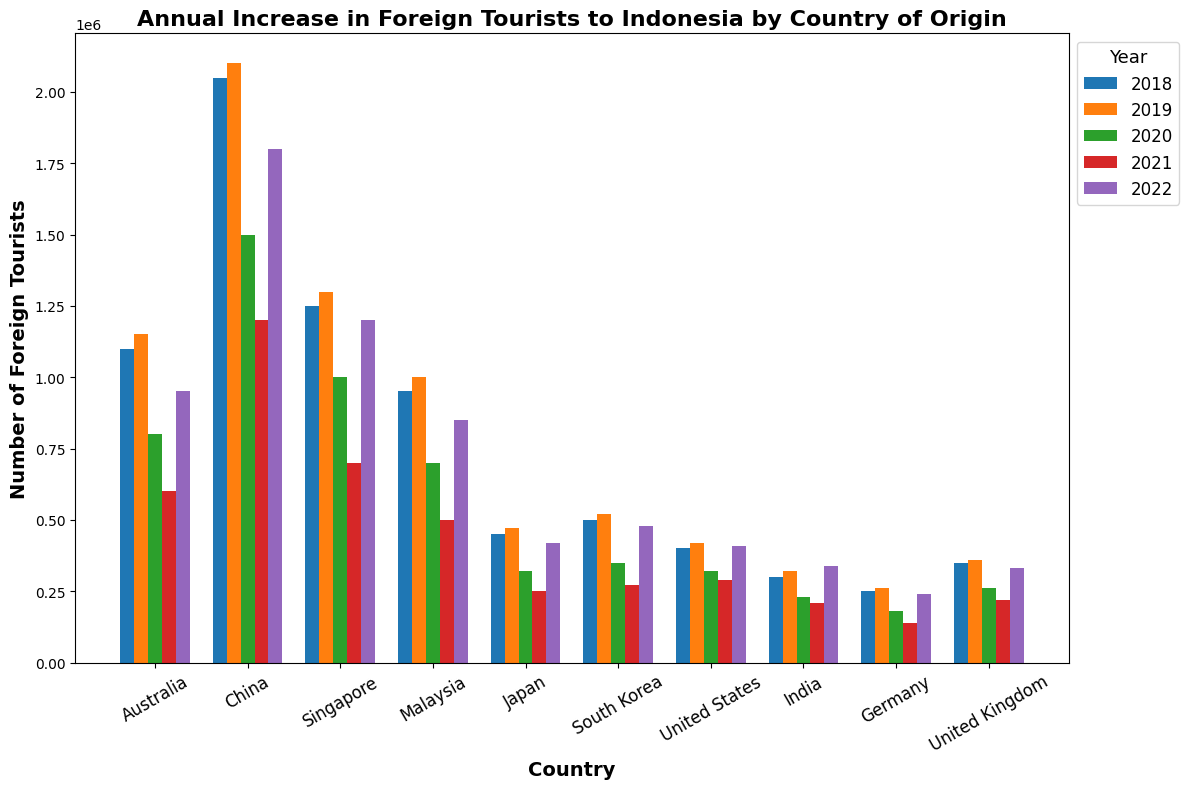Which country had the highest number of foreign tourists to Indonesia in 2022? By looking at the height of the bars for 2022, we can see that China had the highest number of foreign tourists.
Answer: China Which two countries had the least number of foreign tourists to Indonesia in 2021? By observing the bar heights for 2021, we can see that Germany and the United Kingdom had the least number of tourists.
Answer: Germany and United Kingdom What was the difference in the number of foreign tourists from Australia between 2019 and 2020? The bar for Australia in 2019 is at 1,150,000, and the bar for 2020 is at 800,000. The difference is 1,150,000 - 800,000 = 350,000.
Answer: 350,000 Which year had the highest increase in tourists from India compared to the previous year? We'll compare the differences year-over-year for India: 2019-2018 = 20,000, 2020-2019 = -90,000, 2021-2020 = -20,000, 2022-2021 = 130,000. The highest increase is from 2021 to 2022.
Answer: 2022 What is the sum of the number of foreign tourists from the United States across all the years? Summing the bar values for the USA from 2018 through 2022: 400,000 + 420,000 + 320,000 + 290,000 + 410,000 = 1,840,000.
Answer: 1,840,000 Which two countries had the smallest decline in the number of tourists from 2019 to 2020? Calculating the declines: Australia (350,000), China (600,000), Singapore (300,000), Malaysia (300,000), Japan (150,000), South Korea (170,000), USA (100,000), India (90,000), Germany (80,000), UK (100,000). The smallest declines are Germany and India.
Answer: Germany and India What was the average number of foreign tourists from Singapore over the five years? Summing the bar values and dividing by 5: (1,250,000 + 1,300,000 + 1,000,000 + 700,000 + 1,200,000) / 5 = 5,450,000 / 5 = 1,090,000.
Answer: 1,090,000 In which year did Japan see its lowest number of foreign tourists to Indonesia? By looking at the bar heights for Japan, the lowest is in 2021.
Answer: 2021 